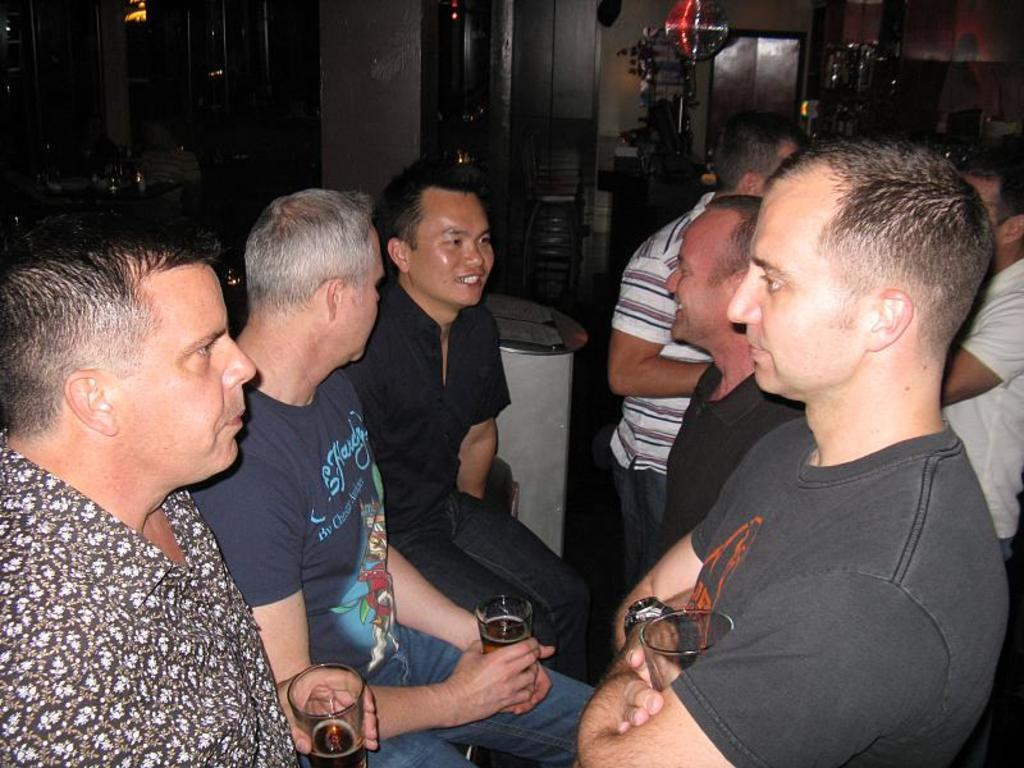How many people are sitting in the image? There are three persons sitting in the image. What are the sitting persons holding? The sitting persons are holding glasses. How many people are standing in the image? There are two persons standing in the image. What can be seen in the background of the image? In the background, there is a group of people standing and cupboards. What type of toothpaste is being used by the person standing in the image? There is no toothpaste present in the image, as it features people sitting and standing with glasses. --- Facts: 1. There is a car in the image. 2. The car is parked on the street. 3. There are trees on both sides of the street. 4. The sky is visible in the image. 5. There is a traffic light in the background. Absurd Topics: parrot, sand, volcano Conversation: What is the main subject of the image? The main subject of the image is a car. Where is the car located in the image? The car is parked on the street. What can be seen on both sides of the street? There are trees on both sides of the street. What is visible in the background of the image? The sky is visible in the image, and there is a traffic light in the background. Reasoning: Let's think step by step in order to produce the conversation. We start by identifying the main subject of the image, which is the car. Then, we describe the car's location, which is parked on the street. Next, we mention the presence of trees on both sides of the street. Finally, we describe the background elements, including the sky and the traffic light. Each question is designed to elicit a specific detail about the image that is known from the provided facts. Absurd Question/Answer: Can you tell me how many parrots are sitting on the car in the image? There are no parrots present in the image; it features a car parked on the street with trees and a traffic light in the background. 